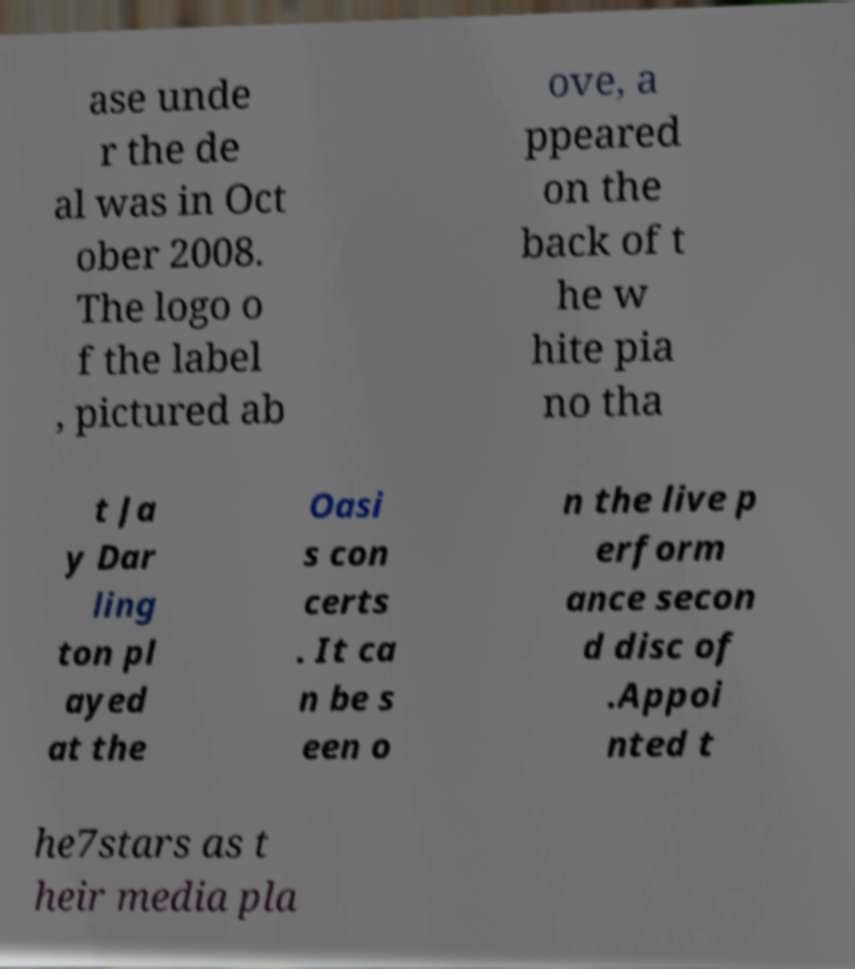What messages or text are displayed in this image? I need them in a readable, typed format. ase unde r the de al was in Oct ober 2008. The logo o f the label , pictured ab ove, a ppeared on the back of t he w hite pia no tha t Ja y Dar ling ton pl ayed at the Oasi s con certs . It ca n be s een o n the live p erform ance secon d disc of .Appoi nted t he7stars as t heir media pla 